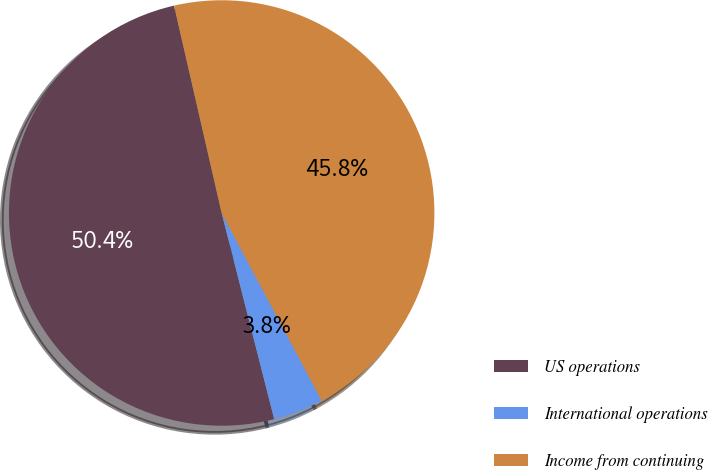Convert chart to OTSL. <chart><loc_0><loc_0><loc_500><loc_500><pie_chart><fcel>US operations<fcel>International operations<fcel>Income from continuing<nl><fcel>50.38%<fcel>3.82%<fcel>45.8%<nl></chart> 